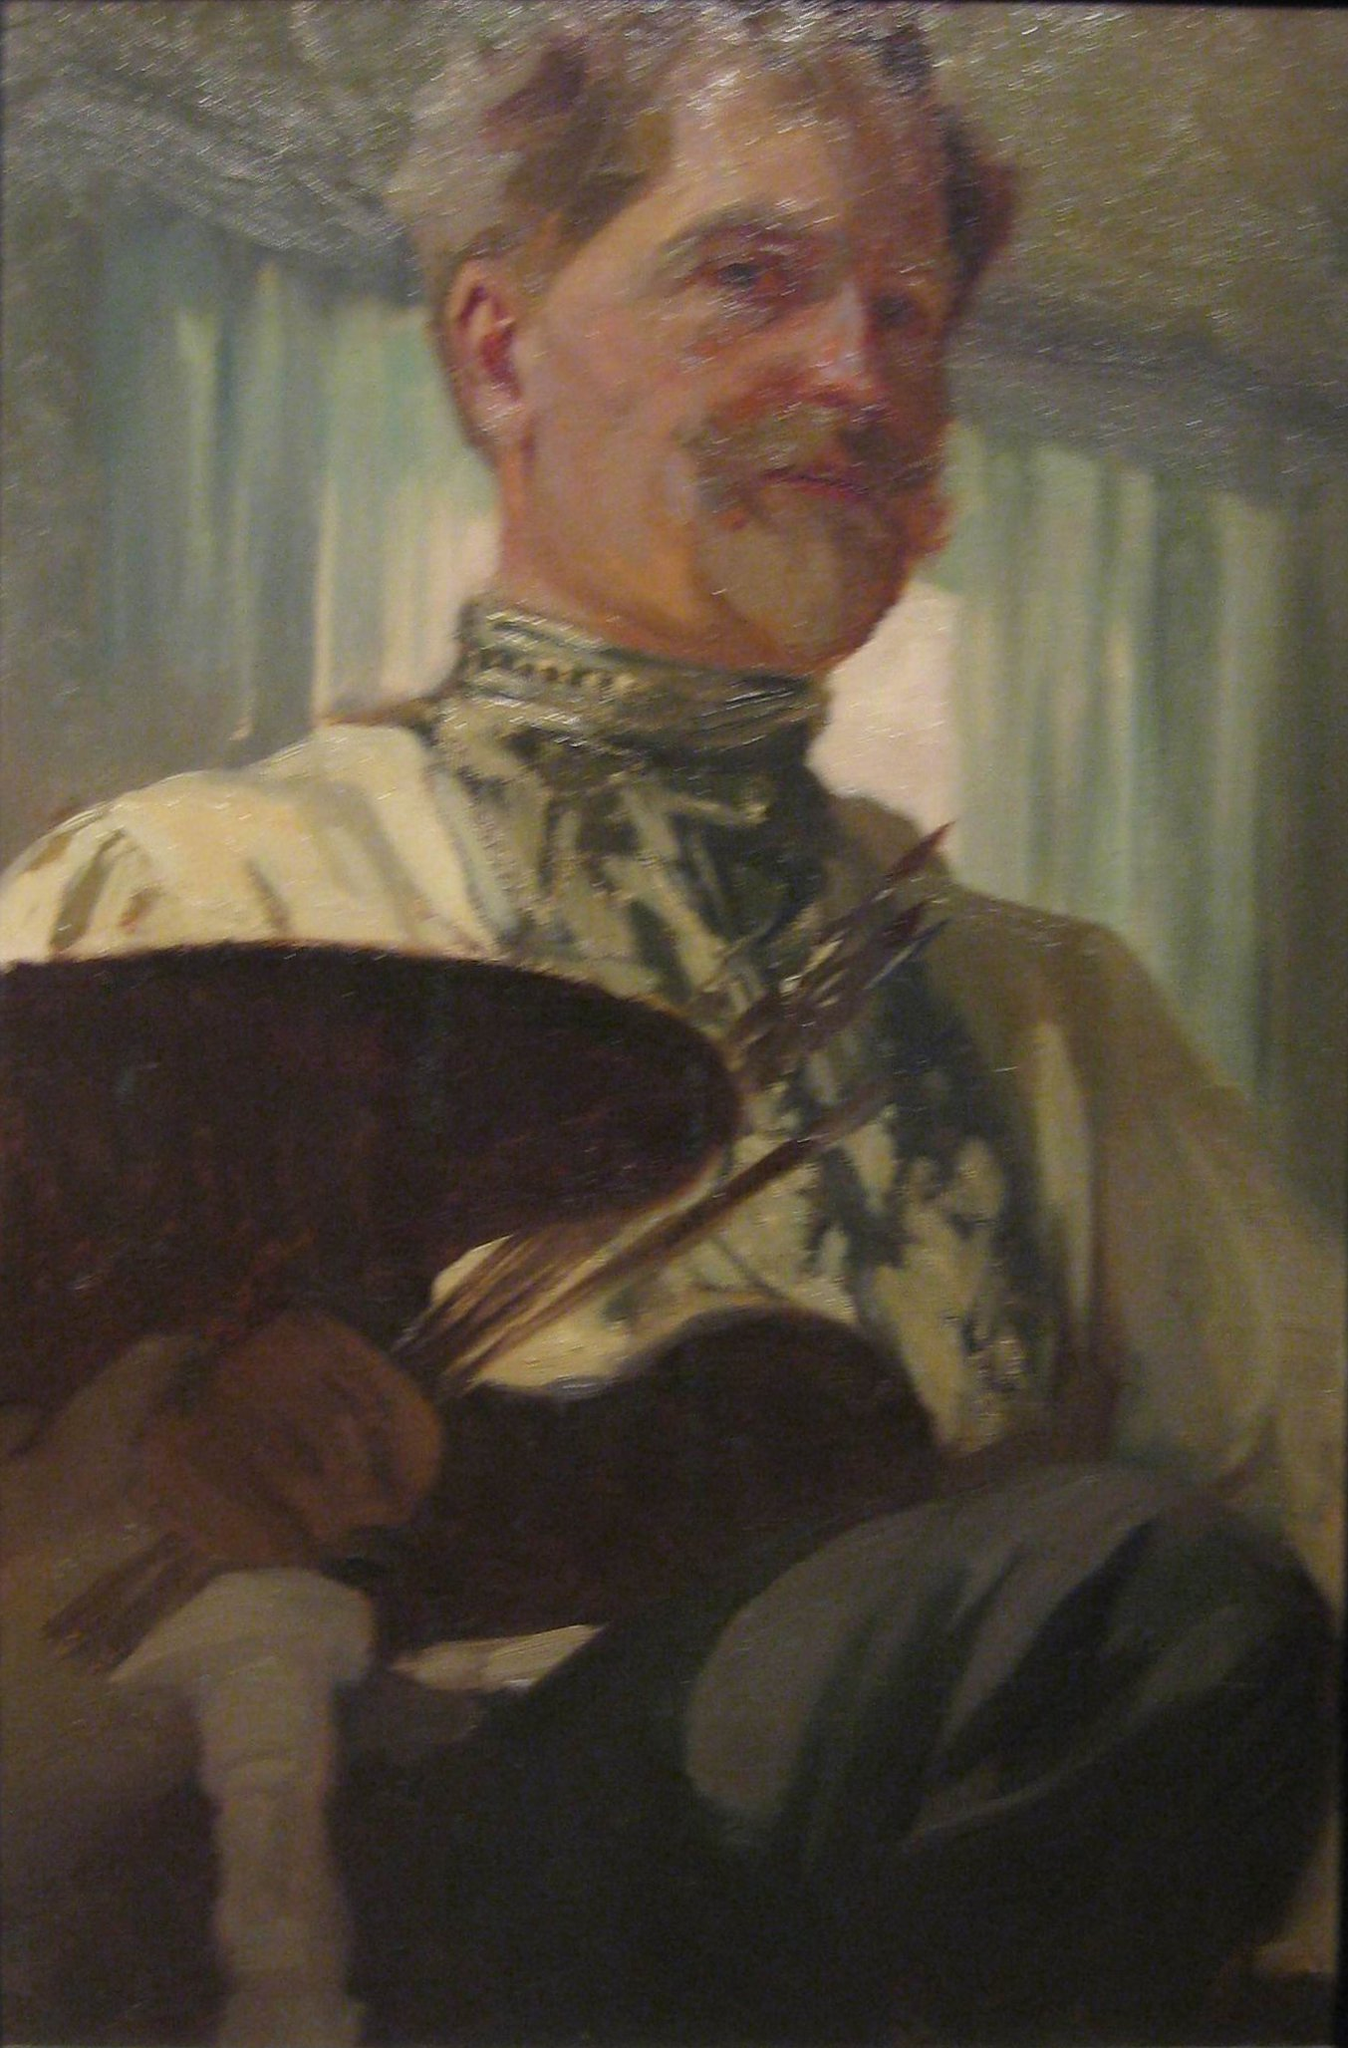Explain the visual content of the image in great detail. The image depicts a man dressed in a traditional artist’s smock, suggesting he is a painter. His attire includes a high, decorative collar and a whitish shirt. He is holding a large wooden palette in one hand, laden with various colored paints, and a cluster of brushes in the other hand, indicating his artistic profession. His graying hair and mustache add character and a sense of maturity to his appearance. The background shows a soft greenish-blue curtain, which helps to highlight the man and create a subtle, serene atmosphere. The painting is executed with a technique that emphasizes textured brushstrokes, giving a sense of movement and personality. The interplay of light and shadow on his face and smock creates a lifelike representation, enhancing the three-dimensionality of the image. Overall, the composition and execution reflect the artist's skill in capturing both the likeness and essence of the subject. 